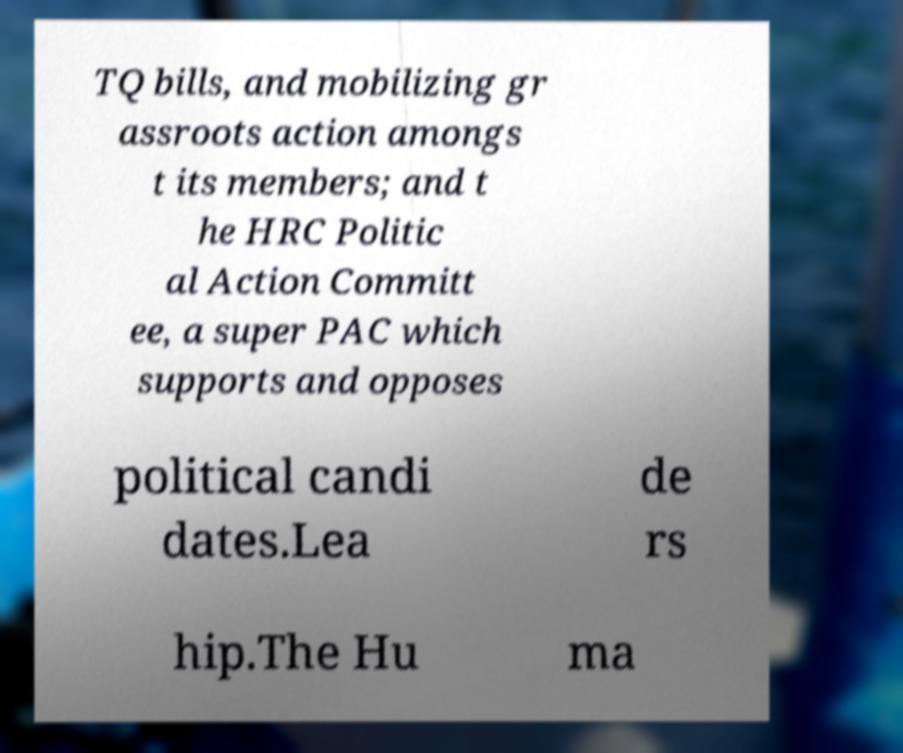Could you extract and type out the text from this image? TQ bills, and mobilizing gr assroots action amongs t its members; and t he HRC Politic al Action Committ ee, a super PAC which supports and opposes political candi dates.Lea de rs hip.The Hu ma 